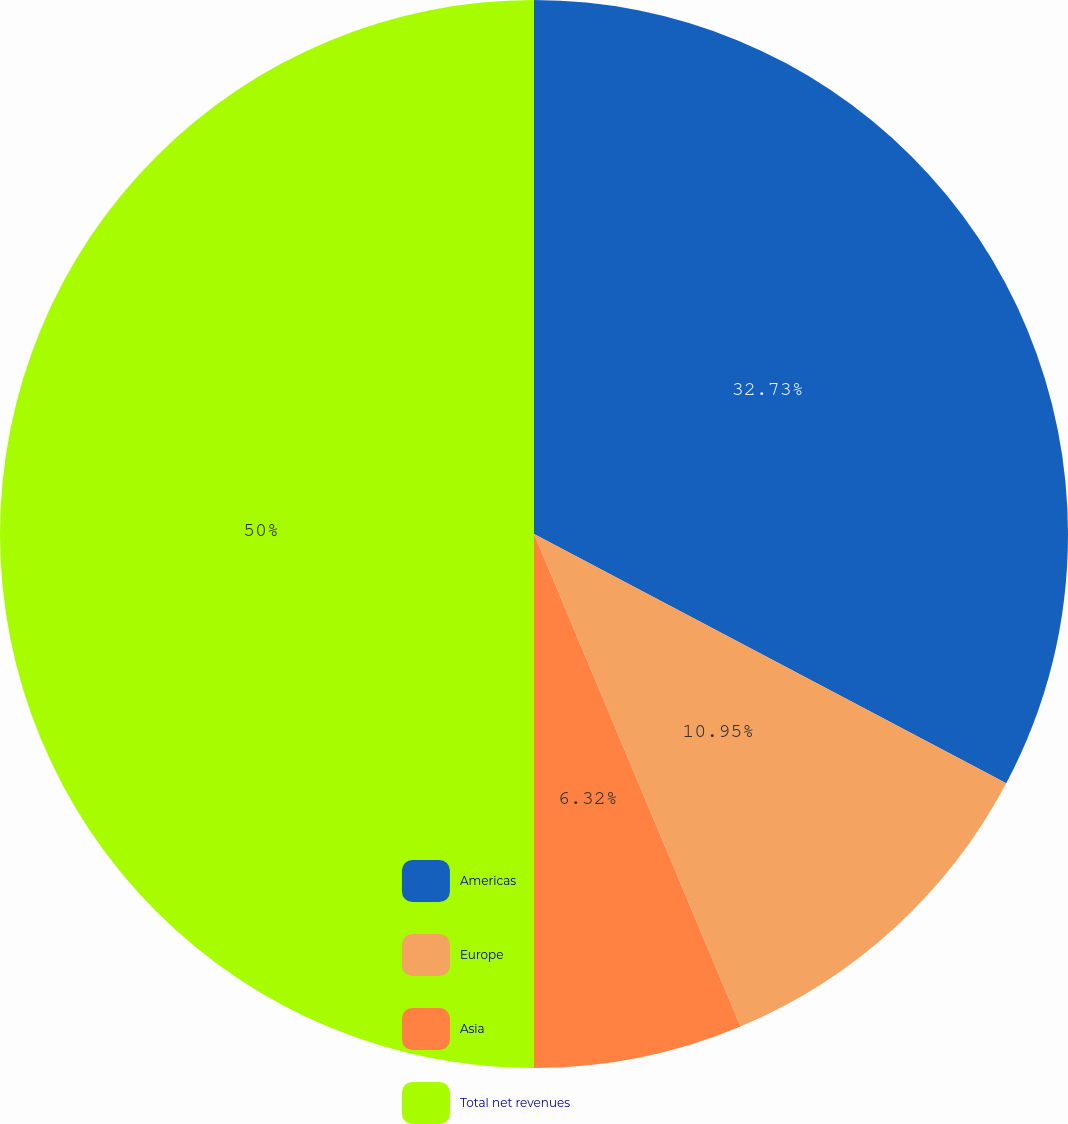<chart> <loc_0><loc_0><loc_500><loc_500><pie_chart><fcel>Americas<fcel>Europe<fcel>Asia<fcel>Total net revenues<nl><fcel>32.73%<fcel>10.95%<fcel>6.32%<fcel>50.0%<nl></chart> 